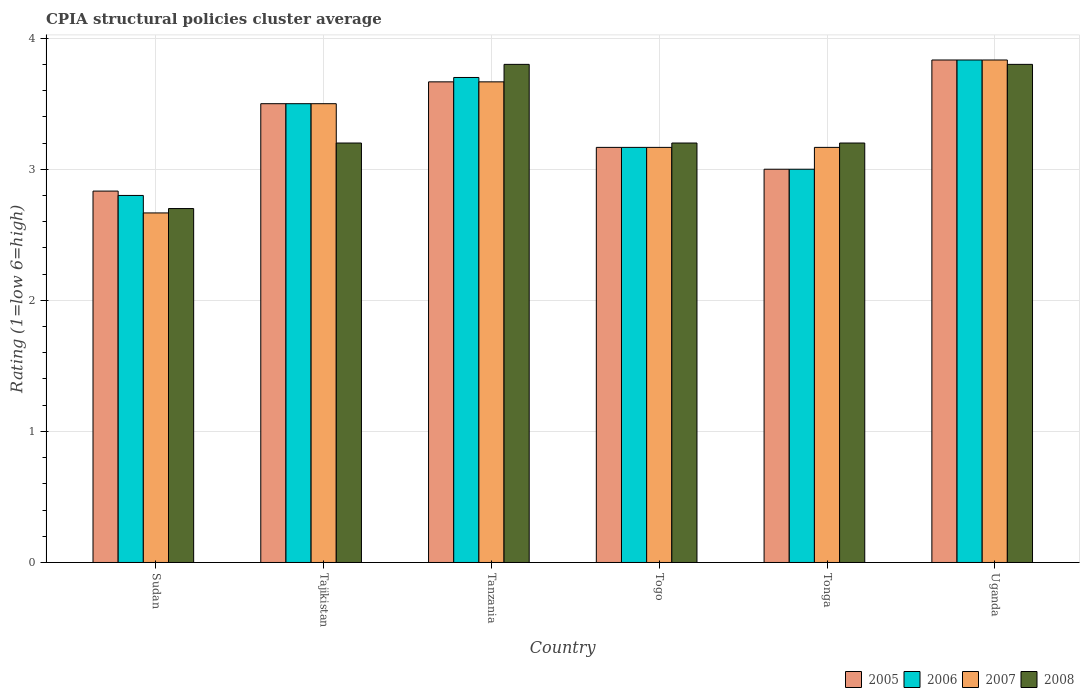How many groups of bars are there?
Keep it short and to the point. 6. Are the number of bars per tick equal to the number of legend labels?
Keep it short and to the point. Yes. How many bars are there on the 5th tick from the left?
Your answer should be compact. 4. How many bars are there on the 2nd tick from the right?
Your answer should be very brief. 4. What is the label of the 4th group of bars from the left?
Make the answer very short. Togo. What is the CPIA rating in 2007 in Tonga?
Your answer should be very brief. 3.17. Across all countries, what is the maximum CPIA rating in 2007?
Provide a short and direct response. 3.83. Across all countries, what is the minimum CPIA rating in 2006?
Your answer should be very brief. 2.8. In which country was the CPIA rating in 2008 maximum?
Ensure brevity in your answer.  Tanzania. In which country was the CPIA rating in 2008 minimum?
Ensure brevity in your answer.  Sudan. What is the difference between the CPIA rating in 2006 in Tanzania and that in Uganda?
Make the answer very short. -0.13. What is the difference between the CPIA rating in 2007 in Uganda and the CPIA rating in 2008 in Tanzania?
Your response must be concise. 0.03. What is the average CPIA rating in 2008 per country?
Offer a very short reply. 3.32. What is the difference between the CPIA rating of/in 2008 and CPIA rating of/in 2005 in Togo?
Your response must be concise. 0.03. In how many countries, is the CPIA rating in 2008 greater than 3.8?
Make the answer very short. 0. What is the ratio of the CPIA rating in 2008 in Sudan to that in Tajikistan?
Offer a terse response. 0.84. Is the CPIA rating in 2007 in Sudan less than that in Togo?
Keep it short and to the point. Yes. Is the difference between the CPIA rating in 2008 in Tajikistan and Togo greater than the difference between the CPIA rating in 2005 in Tajikistan and Togo?
Your answer should be very brief. No. What is the difference between the highest and the second highest CPIA rating in 2008?
Make the answer very short. -0.6. What is the difference between the highest and the lowest CPIA rating in 2008?
Give a very brief answer. 1.1. Is it the case that in every country, the sum of the CPIA rating in 2005 and CPIA rating in 2006 is greater than the sum of CPIA rating in 2007 and CPIA rating in 2008?
Give a very brief answer. No. What does the 4th bar from the left in Tonga represents?
Provide a succinct answer. 2008. How many bars are there?
Provide a short and direct response. 24. Are all the bars in the graph horizontal?
Ensure brevity in your answer.  No. How many countries are there in the graph?
Make the answer very short. 6. Are the values on the major ticks of Y-axis written in scientific E-notation?
Ensure brevity in your answer.  No. Does the graph contain any zero values?
Provide a short and direct response. No. Does the graph contain grids?
Offer a terse response. Yes. How many legend labels are there?
Keep it short and to the point. 4. How are the legend labels stacked?
Offer a terse response. Horizontal. What is the title of the graph?
Offer a very short reply. CPIA structural policies cluster average. Does "1985" appear as one of the legend labels in the graph?
Give a very brief answer. No. What is the label or title of the X-axis?
Ensure brevity in your answer.  Country. What is the Rating (1=low 6=high) in 2005 in Sudan?
Your answer should be compact. 2.83. What is the Rating (1=low 6=high) in 2006 in Sudan?
Give a very brief answer. 2.8. What is the Rating (1=low 6=high) in 2007 in Sudan?
Offer a terse response. 2.67. What is the Rating (1=low 6=high) of 2005 in Tajikistan?
Your response must be concise. 3.5. What is the Rating (1=low 6=high) in 2005 in Tanzania?
Offer a terse response. 3.67. What is the Rating (1=low 6=high) in 2007 in Tanzania?
Offer a very short reply. 3.67. What is the Rating (1=low 6=high) of 2008 in Tanzania?
Offer a very short reply. 3.8. What is the Rating (1=low 6=high) in 2005 in Togo?
Your answer should be very brief. 3.17. What is the Rating (1=low 6=high) of 2006 in Togo?
Offer a very short reply. 3.17. What is the Rating (1=low 6=high) in 2007 in Togo?
Offer a very short reply. 3.17. What is the Rating (1=low 6=high) of 2005 in Tonga?
Provide a short and direct response. 3. What is the Rating (1=low 6=high) of 2007 in Tonga?
Your answer should be compact. 3.17. What is the Rating (1=low 6=high) of 2008 in Tonga?
Your answer should be compact. 3.2. What is the Rating (1=low 6=high) in 2005 in Uganda?
Provide a succinct answer. 3.83. What is the Rating (1=low 6=high) in 2006 in Uganda?
Your answer should be very brief. 3.83. What is the Rating (1=low 6=high) of 2007 in Uganda?
Give a very brief answer. 3.83. Across all countries, what is the maximum Rating (1=low 6=high) of 2005?
Provide a short and direct response. 3.83. Across all countries, what is the maximum Rating (1=low 6=high) of 2006?
Your answer should be very brief. 3.83. Across all countries, what is the maximum Rating (1=low 6=high) in 2007?
Make the answer very short. 3.83. Across all countries, what is the minimum Rating (1=low 6=high) of 2005?
Make the answer very short. 2.83. Across all countries, what is the minimum Rating (1=low 6=high) in 2006?
Offer a terse response. 2.8. Across all countries, what is the minimum Rating (1=low 6=high) in 2007?
Provide a short and direct response. 2.67. Across all countries, what is the minimum Rating (1=low 6=high) in 2008?
Provide a succinct answer. 2.7. What is the total Rating (1=low 6=high) in 2008 in the graph?
Your response must be concise. 19.9. What is the difference between the Rating (1=low 6=high) in 2006 in Sudan and that in Tajikistan?
Offer a terse response. -0.7. What is the difference between the Rating (1=low 6=high) in 2008 in Sudan and that in Tajikistan?
Offer a very short reply. -0.5. What is the difference between the Rating (1=low 6=high) in 2005 in Sudan and that in Tanzania?
Ensure brevity in your answer.  -0.83. What is the difference between the Rating (1=low 6=high) in 2006 in Sudan and that in Togo?
Offer a very short reply. -0.37. What is the difference between the Rating (1=low 6=high) in 2008 in Sudan and that in Togo?
Your answer should be very brief. -0.5. What is the difference between the Rating (1=low 6=high) of 2006 in Sudan and that in Tonga?
Give a very brief answer. -0.2. What is the difference between the Rating (1=low 6=high) of 2006 in Sudan and that in Uganda?
Your response must be concise. -1.03. What is the difference between the Rating (1=low 6=high) of 2007 in Sudan and that in Uganda?
Give a very brief answer. -1.17. What is the difference between the Rating (1=low 6=high) in 2008 in Sudan and that in Uganda?
Your response must be concise. -1.1. What is the difference between the Rating (1=low 6=high) in 2005 in Tajikistan and that in Tanzania?
Make the answer very short. -0.17. What is the difference between the Rating (1=low 6=high) in 2006 in Tajikistan and that in Tanzania?
Offer a terse response. -0.2. What is the difference between the Rating (1=low 6=high) in 2008 in Tajikistan and that in Togo?
Your response must be concise. 0. What is the difference between the Rating (1=low 6=high) in 2005 in Tajikistan and that in Uganda?
Offer a terse response. -0.33. What is the difference between the Rating (1=low 6=high) of 2006 in Tajikistan and that in Uganda?
Provide a succinct answer. -0.33. What is the difference between the Rating (1=low 6=high) in 2005 in Tanzania and that in Togo?
Your response must be concise. 0.5. What is the difference between the Rating (1=low 6=high) in 2006 in Tanzania and that in Togo?
Provide a short and direct response. 0.53. What is the difference between the Rating (1=low 6=high) in 2007 in Tanzania and that in Togo?
Offer a terse response. 0.5. What is the difference between the Rating (1=low 6=high) in 2005 in Tanzania and that in Tonga?
Provide a short and direct response. 0.67. What is the difference between the Rating (1=low 6=high) of 2006 in Tanzania and that in Tonga?
Provide a short and direct response. 0.7. What is the difference between the Rating (1=low 6=high) in 2005 in Tanzania and that in Uganda?
Give a very brief answer. -0.17. What is the difference between the Rating (1=low 6=high) in 2006 in Tanzania and that in Uganda?
Keep it short and to the point. -0.13. What is the difference between the Rating (1=low 6=high) in 2005 in Togo and that in Uganda?
Give a very brief answer. -0.67. What is the difference between the Rating (1=low 6=high) of 2007 in Togo and that in Uganda?
Provide a short and direct response. -0.67. What is the difference between the Rating (1=low 6=high) in 2006 in Tonga and that in Uganda?
Make the answer very short. -0.83. What is the difference between the Rating (1=low 6=high) in 2007 in Tonga and that in Uganda?
Provide a short and direct response. -0.67. What is the difference between the Rating (1=low 6=high) in 2005 in Sudan and the Rating (1=low 6=high) in 2006 in Tajikistan?
Provide a succinct answer. -0.67. What is the difference between the Rating (1=low 6=high) in 2005 in Sudan and the Rating (1=low 6=high) in 2008 in Tajikistan?
Offer a very short reply. -0.37. What is the difference between the Rating (1=low 6=high) in 2006 in Sudan and the Rating (1=low 6=high) in 2008 in Tajikistan?
Provide a succinct answer. -0.4. What is the difference between the Rating (1=low 6=high) of 2007 in Sudan and the Rating (1=low 6=high) of 2008 in Tajikistan?
Provide a succinct answer. -0.53. What is the difference between the Rating (1=low 6=high) in 2005 in Sudan and the Rating (1=low 6=high) in 2006 in Tanzania?
Offer a very short reply. -0.87. What is the difference between the Rating (1=low 6=high) in 2005 in Sudan and the Rating (1=low 6=high) in 2008 in Tanzania?
Keep it short and to the point. -0.97. What is the difference between the Rating (1=low 6=high) in 2006 in Sudan and the Rating (1=low 6=high) in 2007 in Tanzania?
Keep it short and to the point. -0.87. What is the difference between the Rating (1=low 6=high) of 2007 in Sudan and the Rating (1=low 6=high) of 2008 in Tanzania?
Give a very brief answer. -1.13. What is the difference between the Rating (1=low 6=high) in 2005 in Sudan and the Rating (1=low 6=high) in 2008 in Togo?
Give a very brief answer. -0.37. What is the difference between the Rating (1=low 6=high) of 2006 in Sudan and the Rating (1=low 6=high) of 2007 in Togo?
Make the answer very short. -0.37. What is the difference between the Rating (1=low 6=high) of 2007 in Sudan and the Rating (1=low 6=high) of 2008 in Togo?
Offer a very short reply. -0.53. What is the difference between the Rating (1=low 6=high) of 2005 in Sudan and the Rating (1=low 6=high) of 2006 in Tonga?
Ensure brevity in your answer.  -0.17. What is the difference between the Rating (1=low 6=high) of 2005 in Sudan and the Rating (1=low 6=high) of 2008 in Tonga?
Ensure brevity in your answer.  -0.37. What is the difference between the Rating (1=low 6=high) in 2006 in Sudan and the Rating (1=low 6=high) in 2007 in Tonga?
Give a very brief answer. -0.37. What is the difference between the Rating (1=low 6=high) of 2007 in Sudan and the Rating (1=low 6=high) of 2008 in Tonga?
Keep it short and to the point. -0.53. What is the difference between the Rating (1=low 6=high) in 2005 in Sudan and the Rating (1=low 6=high) in 2006 in Uganda?
Give a very brief answer. -1. What is the difference between the Rating (1=low 6=high) of 2005 in Sudan and the Rating (1=low 6=high) of 2008 in Uganda?
Ensure brevity in your answer.  -0.97. What is the difference between the Rating (1=low 6=high) in 2006 in Sudan and the Rating (1=low 6=high) in 2007 in Uganda?
Offer a very short reply. -1.03. What is the difference between the Rating (1=low 6=high) of 2006 in Sudan and the Rating (1=low 6=high) of 2008 in Uganda?
Keep it short and to the point. -1. What is the difference between the Rating (1=low 6=high) in 2007 in Sudan and the Rating (1=low 6=high) in 2008 in Uganda?
Give a very brief answer. -1.13. What is the difference between the Rating (1=low 6=high) in 2005 in Tajikistan and the Rating (1=low 6=high) in 2006 in Tanzania?
Make the answer very short. -0.2. What is the difference between the Rating (1=low 6=high) in 2006 in Tajikistan and the Rating (1=low 6=high) in 2008 in Tanzania?
Your answer should be very brief. -0.3. What is the difference between the Rating (1=low 6=high) in 2007 in Tajikistan and the Rating (1=low 6=high) in 2008 in Tanzania?
Your answer should be very brief. -0.3. What is the difference between the Rating (1=low 6=high) of 2006 in Tajikistan and the Rating (1=low 6=high) of 2007 in Togo?
Your answer should be compact. 0.33. What is the difference between the Rating (1=low 6=high) in 2007 in Tajikistan and the Rating (1=low 6=high) in 2008 in Togo?
Your answer should be compact. 0.3. What is the difference between the Rating (1=low 6=high) in 2005 in Tajikistan and the Rating (1=low 6=high) in 2008 in Tonga?
Your answer should be compact. 0.3. What is the difference between the Rating (1=low 6=high) in 2006 in Tajikistan and the Rating (1=low 6=high) in 2008 in Tonga?
Keep it short and to the point. 0.3. What is the difference between the Rating (1=low 6=high) of 2007 in Tajikistan and the Rating (1=low 6=high) of 2008 in Tonga?
Your answer should be very brief. 0.3. What is the difference between the Rating (1=low 6=high) in 2005 in Tajikistan and the Rating (1=low 6=high) in 2006 in Uganda?
Provide a succinct answer. -0.33. What is the difference between the Rating (1=low 6=high) in 2005 in Tajikistan and the Rating (1=low 6=high) in 2008 in Uganda?
Make the answer very short. -0.3. What is the difference between the Rating (1=low 6=high) of 2006 in Tajikistan and the Rating (1=low 6=high) of 2007 in Uganda?
Your answer should be very brief. -0.33. What is the difference between the Rating (1=low 6=high) in 2006 in Tajikistan and the Rating (1=low 6=high) in 2008 in Uganda?
Your answer should be very brief. -0.3. What is the difference between the Rating (1=low 6=high) in 2005 in Tanzania and the Rating (1=low 6=high) in 2006 in Togo?
Make the answer very short. 0.5. What is the difference between the Rating (1=low 6=high) of 2005 in Tanzania and the Rating (1=low 6=high) of 2008 in Togo?
Your answer should be compact. 0.47. What is the difference between the Rating (1=low 6=high) of 2006 in Tanzania and the Rating (1=low 6=high) of 2007 in Togo?
Ensure brevity in your answer.  0.53. What is the difference between the Rating (1=low 6=high) of 2007 in Tanzania and the Rating (1=low 6=high) of 2008 in Togo?
Your answer should be very brief. 0.47. What is the difference between the Rating (1=low 6=high) of 2005 in Tanzania and the Rating (1=low 6=high) of 2008 in Tonga?
Offer a very short reply. 0.47. What is the difference between the Rating (1=low 6=high) of 2006 in Tanzania and the Rating (1=low 6=high) of 2007 in Tonga?
Your answer should be compact. 0.53. What is the difference between the Rating (1=low 6=high) in 2007 in Tanzania and the Rating (1=low 6=high) in 2008 in Tonga?
Offer a very short reply. 0.47. What is the difference between the Rating (1=low 6=high) of 2005 in Tanzania and the Rating (1=low 6=high) of 2006 in Uganda?
Provide a succinct answer. -0.17. What is the difference between the Rating (1=low 6=high) of 2005 in Tanzania and the Rating (1=low 6=high) of 2007 in Uganda?
Keep it short and to the point. -0.17. What is the difference between the Rating (1=low 6=high) in 2005 in Tanzania and the Rating (1=low 6=high) in 2008 in Uganda?
Ensure brevity in your answer.  -0.13. What is the difference between the Rating (1=low 6=high) of 2006 in Tanzania and the Rating (1=low 6=high) of 2007 in Uganda?
Your answer should be very brief. -0.13. What is the difference between the Rating (1=low 6=high) in 2007 in Tanzania and the Rating (1=low 6=high) in 2008 in Uganda?
Your answer should be very brief. -0.13. What is the difference between the Rating (1=low 6=high) of 2005 in Togo and the Rating (1=low 6=high) of 2007 in Tonga?
Ensure brevity in your answer.  0. What is the difference between the Rating (1=low 6=high) in 2005 in Togo and the Rating (1=low 6=high) in 2008 in Tonga?
Provide a short and direct response. -0.03. What is the difference between the Rating (1=low 6=high) of 2006 in Togo and the Rating (1=low 6=high) of 2008 in Tonga?
Your answer should be compact. -0.03. What is the difference between the Rating (1=low 6=high) in 2007 in Togo and the Rating (1=low 6=high) in 2008 in Tonga?
Keep it short and to the point. -0.03. What is the difference between the Rating (1=low 6=high) in 2005 in Togo and the Rating (1=low 6=high) in 2006 in Uganda?
Offer a very short reply. -0.67. What is the difference between the Rating (1=low 6=high) of 2005 in Togo and the Rating (1=low 6=high) of 2007 in Uganda?
Your response must be concise. -0.67. What is the difference between the Rating (1=low 6=high) in 2005 in Togo and the Rating (1=low 6=high) in 2008 in Uganda?
Your answer should be compact. -0.63. What is the difference between the Rating (1=low 6=high) of 2006 in Togo and the Rating (1=low 6=high) of 2007 in Uganda?
Your response must be concise. -0.67. What is the difference between the Rating (1=low 6=high) of 2006 in Togo and the Rating (1=low 6=high) of 2008 in Uganda?
Offer a very short reply. -0.63. What is the difference between the Rating (1=low 6=high) of 2007 in Togo and the Rating (1=low 6=high) of 2008 in Uganda?
Your answer should be very brief. -0.63. What is the difference between the Rating (1=low 6=high) in 2005 in Tonga and the Rating (1=low 6=high) in 2007 in Uganda?
Your response must be concise. -0.83. What is the difference between the Rating (1=low 6=high) in 2005 in Tonga and the Rating (1=low 6=high) in 2008 in Uganda?
Your response must be concise. -0.8. What is the difference between the Rating (1=low 6=high) in 2007 in Tonga and the Rating (1=low 6=high) in 2008 in Uganda?
Provide a short and direct response. -0.63. What is the average Rating (1=low 6=high) of 2005 per country?
Provide a succinct answer. 3.33. What is the average Rating (1=low 6=high) of 2008 per country?
Provide a short and direct response. 3.32. What is the difference between the Rating (1=low 6=high) of 2005 and Rating (1=low 6=high) of 2007 in Sudan?
Your answer should be very brief. 0.17. What is the difference between the Rating (1=low 6=high) in 2005 and Rating (1=low 6=high) in 2008 in Sudan?
Provide a succinct answer. 0.13. What is the difference between the Rating (1=low 6=high) in 2006 and Rating (1=low 6=high) in 2007 in Sudan?
Provide a short and direct response. 0.13. What is the difference between the Rating (1=low 6=high) of 2006 and Rating (1=low 6=high) of 2008 in Sudan?
Provide a short and direct response. 0.1. What is the difference between the Rating (1=low 6=high) of 2007 and Rating (1=low 6=high) of 2008 in Sudan?
Keep it short and to the point. -0.03. What is the difference between the Rating (1=low 6=high) of 2005 and Rating (1=low 6=high) of 2007 in Tajikistan?
Offer a very short reply. 0. What is the difference between the Rating (1=low 6=high) in 2007 and Rating (1=low 6=high) in 2008 in Tajikistan?
Your response must be concise. 0.3. What is the difference between the Rating (1=low 6=high) of 2005 and Rating (1=low 6=high) of 2006 in Tanzania?
Your response must be concise. -0.03. What is the difference between the Rating (1=low 6=high) in 2005 and Rating (1=low 6=high) in 2008 in Tanzania?
Provide a succinct answer. -0.13. What is the difference between the Rating (1=low 6=high) in 2006 and Rating (1=low 6=high) in 2007 in Tanzania?
Your response must be concise. 0.03. What is the difference between the Rating (1=low 6=high) of 2006 and Rating (1=low 6=high) of 2008 in Tanzania?
Your response must be concise. -0.1. What is the difference between the Rating (1=low 6=high) in 2007 and Rating (1=low 6=high) in 2008 in Tanzania?
Give a very brief answer. -0.13. What is the difference between the Rating (1=low 6=high) of 2005 and Rating (1=low 6=high) of 2006 in Togo?
Offer a very short reply. 0. What is the difference between the Rating (1=low 6=high) of 2005 and Rating (1=low 6=high) of 2007 in Togo?
Your answer should be compact. 0. What is the difference between the Rating (1=low 6=high) in 2005 and Rating (1=low 6=high) in 2008 in Togo?
Give a very brief answer. -0.03. What is the difference between the Rating (1=low 6=high) of 2006 and Rating (1=low 6=high) of 2007 in Togo?
Make the answer very short. 0. What is the difference between the Rating (1=low 6=high) of 2006 and Rating (1=low 6=high) of 2008 in Togo?
Make the answer very short. -0.03. What is the difference between the Rating (1=low 6=high) of 2007 and Rating (1=low 6=high) of 2008 in Togo?
Offer a terse response. -0.03. What is the difference between the Rating (1=low 6=high) of 2006 and Rating (1=low 6=high) of 2008 in Tonga?
Give a very brief answer. -0.2. What is the difference between the Rating (1=low 6=high) of 2007 and Rating (1=low 6=high) of 2008 in Tonga?
Make the answer very short. -0.03. What is the difference between the Rating (1=low 6=high) of 2005 and Rating (1=low 6=high) of 2008 in Uganda?
Give a very brief answer. 0.03. What is the difference between the Rating (1=low 6=high) of 2006 and Rating (1=low 6=high) of 2008 in Uganda?
Offer a terse response. 0.03. What is the difference between the Rating (1=low 6=high) in 2007 and Rating (1=low 6=high) in 2008 in Uganda?
Give a very brief answer. 0.03. What is the ratio of the Rating (1=low 6=high) of 2005 in Sudan to that in Tajikistan?
Ensure brevity in your answer.  0.81. What is the ratio of the Rating (1=low 6=high) of 2007 in Sudan to that in Tajikistan?
Give a very brief answer. 0.76. What is the ratio of the Rating (1=low 6=high) in 2008 in Sudan to that in Tajikistan?
Your response must be concise. 0.84. What is the ratio of the Rating (1=low 6=high) in 2005 in Sudan to that in Tanzania?
Your response must be concise. 0.77. What is the ratio of the Rating (1=low 6=high) in 2006 in Sudan to that in Tanzania?
Offer a very short reply. 0.76. What is the ratio of the Rating (1=low 6=high) of 2007 in Sudan to that in Tanzania?
Give a very brief answer. 0.73. What is the ratio of the Rating (1=low 6=high) in 2008 in Sudan to that in Tanzania?
Provide a short and direct response. 0.71. What is the ratio of the Rating (1=low 6=high) of 2005 in Sudan to that in Togo?
Keep it short and to the point. 0.89. What is the ratio of the Rating (1=low 6=high) in 2006 in Sudan to that in Togo?
Your answer should be very brief. 0.88. What is the ratio of the Rating (1=low 6=high) of 2007 in Sudan to that in Togo?
Ensure brevity in your answer.  0.84. What is the ratio of the Rating (1=low 6=high) of 2008 in Sudan to that in Togo?
Provide a short and direct response. 0.84. What is the ratio of the Rating (1=low 6=high) in 2007 in Sudan to that in Tonga?
Provide a succinct answer. 0.84. What is the ratio of the Rating (1=low 6=high) of 2008 in Sudan to that in Tonga?
Your answer should be very brief. 0.84. What is the ratio of the Rating (1=low 6=high) of 2005 in Sudan to that in Uganda?
Make the answer very short. 0.74. What is the ratio of the Rating (1=low 6=high) of 2006 in Sudan to that in Uganda?
Your answer should be compact. 0.73. What is the ratio of the Rating (1=low 6=high) in 2007 in Sudan to that in Uganda?
Provide a short and direct response. 0.7. What is the ratio of the Rating (1=low 6=high) in 2008 in Sudan to that in Uganda?
Your response must be concise. 0.71. What is the ratio of the Rating (1=low 6=high) of 2005 in Tajikistan to that in Tanzania?
Your response must be concise. 0.95. What is the ratio of the Rating (1=low 6=high) of 2006 in Tajikistan to that in Tanzania?
Make the answer very short. 0.95. What is the ratio of the Rating (1=low 6=high) in 2007 in Tajikistan to that in Tanzania?
Provide a short and direct response. 0.95. What is the ratio of the Rating (1=low 6=high) in 2008 in Tajikistan to that in Tanzania?
Give a very brief answer. 0.84. What is the ratio of the Rating (1=low 6=high) of 2005 in Tajikistan to that in Togo?
Keep it short and to the point. 1.11. What is the ratio of the Rating (1=low 6=high) of 2006 in Tajikistan to that in Togo?
Your response must be concise. 1.11. What is the ratio of the Rating (1=low 6=high) of 2007 in Tajikistan to that in Togo?
Offer a very short reply. 1.11. What is the ratio of the Rating (1=low 6=high) in 2008 in Tajikistan to that in Togo?
Make the answer very short. 1. What is the ratio of the Rating (1=low 6=high) of 2005 in Tajikistan to that in Tonga?
Keep it short and to the point. 1.17. What is the ratio of the Rating (1=low 6=high) in 2007 in Tajikistan to that in Tonga?
Offer a terse response. 1.11. What is the ratio of the Rating (1=low 6=high) in 2008 in Tajikistan to that in Tonga?
Make the answer very short. 1. What is the ratio of the Rating (1=low 6=high) in 2007 in Tajikistan to that in Uganda?
Provide a short and direct response. 0.91. What is the ratio of the Rating (1=low 6=high) in 2008 in Tajikistan to that in Uganda?
Give a very brief answer. 0.84. What is the ratio of the Rating (1=low 6=high) of 2005 in Tanzania to that in Togo?
Your response must be concise. 1.16. What is the ratio of the Rating (1=low 6=high) in 2006 in Tanzania to that in Togo?
Keep it short and to the point. 1.17. What is the ratio of the Rating (1=low 6=high) in 2007 in Tanzania to that in Togo?
Make the answer very short. 1.16. What is the ratio of the Rating (1=low 6=high) of 2008 in Tanzania to that in Togo?
Provide a succinct answer. 1.19. What is the ratio of the Rating (1=low 6=high) of 2005 in Tanzania to that in Tonga?
Offer a terse response. 1.22. What is the ratio of the Rating (1=low 6=high) of 2006 in Tanzania to that in Tonga?
Provide a succinct answer. 1.23. What is the ratio of the Rating (1=low 6=high) in 2007 in Tanzania to that in Tonga?
Make the answer very short. 1.16. What is the ratio of the Rating (1=low 6=high) of 2008 in Tanzania to that in Tonga?
Keep it short and to the point. 1.19. What is the ratio of the Rating (1=low 6=high) in 2005 in Tanzania to that in Uganda?
Ensure brevity in your answer.  0.96. What is the ratio of the Rating (1=low 6=high) in 2006 in Tanzania to that in Uganda?
Provide a short and direct response. 0.97. What is the ratio of the Rating (1=low 6=high) in 2007 in Tanzania to that in Uganda?
Offer a very short reply. 0.96. What is the ratio of the Rating (1=low 6=high) of 2008 in Tanzania to that in Uganda?
Offer a very short reply. 1. What is the ratio of the Rating (1=low 6=high) of 2005 in Togo to that in Tonga?
Your answer should be compact. 1.06. What is the ratio of the Rating (1=low 6=high) in 2006 in Togo to that in Tonga?
Offer a terse response. 1.06. What is the ratio of the Rating (1=low 6=high) in 2008 in Togo to that in Tonga?
Your response must be concise. 1. What is the ratio of the Rating (1=low 6=high) in 2005 in Togo to that in Uganda?
Ensure brevity in your answer.  0.83. What is the ratio of the Rating (1=low 6=high) in 2006 in Togo to that in Uganda?
Provide a succinct answer. 0.83. What is the ratio of the Rating (1=low 6=high) in 2007 in Togo to that in Uganda?
Offer a terse response. 0.83. What is the ratio of the Rating (1=low 6=high) of 2008 in Togo to that in Uganda?
Your answer should be compact. 0.84. What is the ratio of the Rating (1=low 6=high) of 2005 in Tonga to that in Uganda?
Make the answer very short. 0.78. What is the ratio of the Rating (1=low 6=high) in 2006 in Tonga to that in Uganda?
Provide a succinct answer. 0.78. What is the ratio of the Rating (1=low 6=high) of 2007 in Tonga to that in Uganda?
Ensure brevity in your answer.  0.83. What is the ratio of the Rating (1=low 6=high) in 2008 in Tonga to that in Uganda?
Your answer should be very brief. 0.84. What is the difference between the highest and the second highest Rating (1=low 6=high) in 2005?
Offer a terse response. 0.17. What is the difference between the highest and the second highest Rating (1=low 6=high) of 2006?
Give a very brief answer. 0.13. What is the difference between the highest and the second highest Rating (1=low 6=high) of 2007?
Your answer should be compact. 0.17. What is the difference between the highest and the second highest Rating (1=low 6=high) in 2008?
Keep it short and to the point. 0. What is the difference between the highest and the lowest Rating (1=low 6=high) in 2006?
Provide a short and direct response. 1.03. 